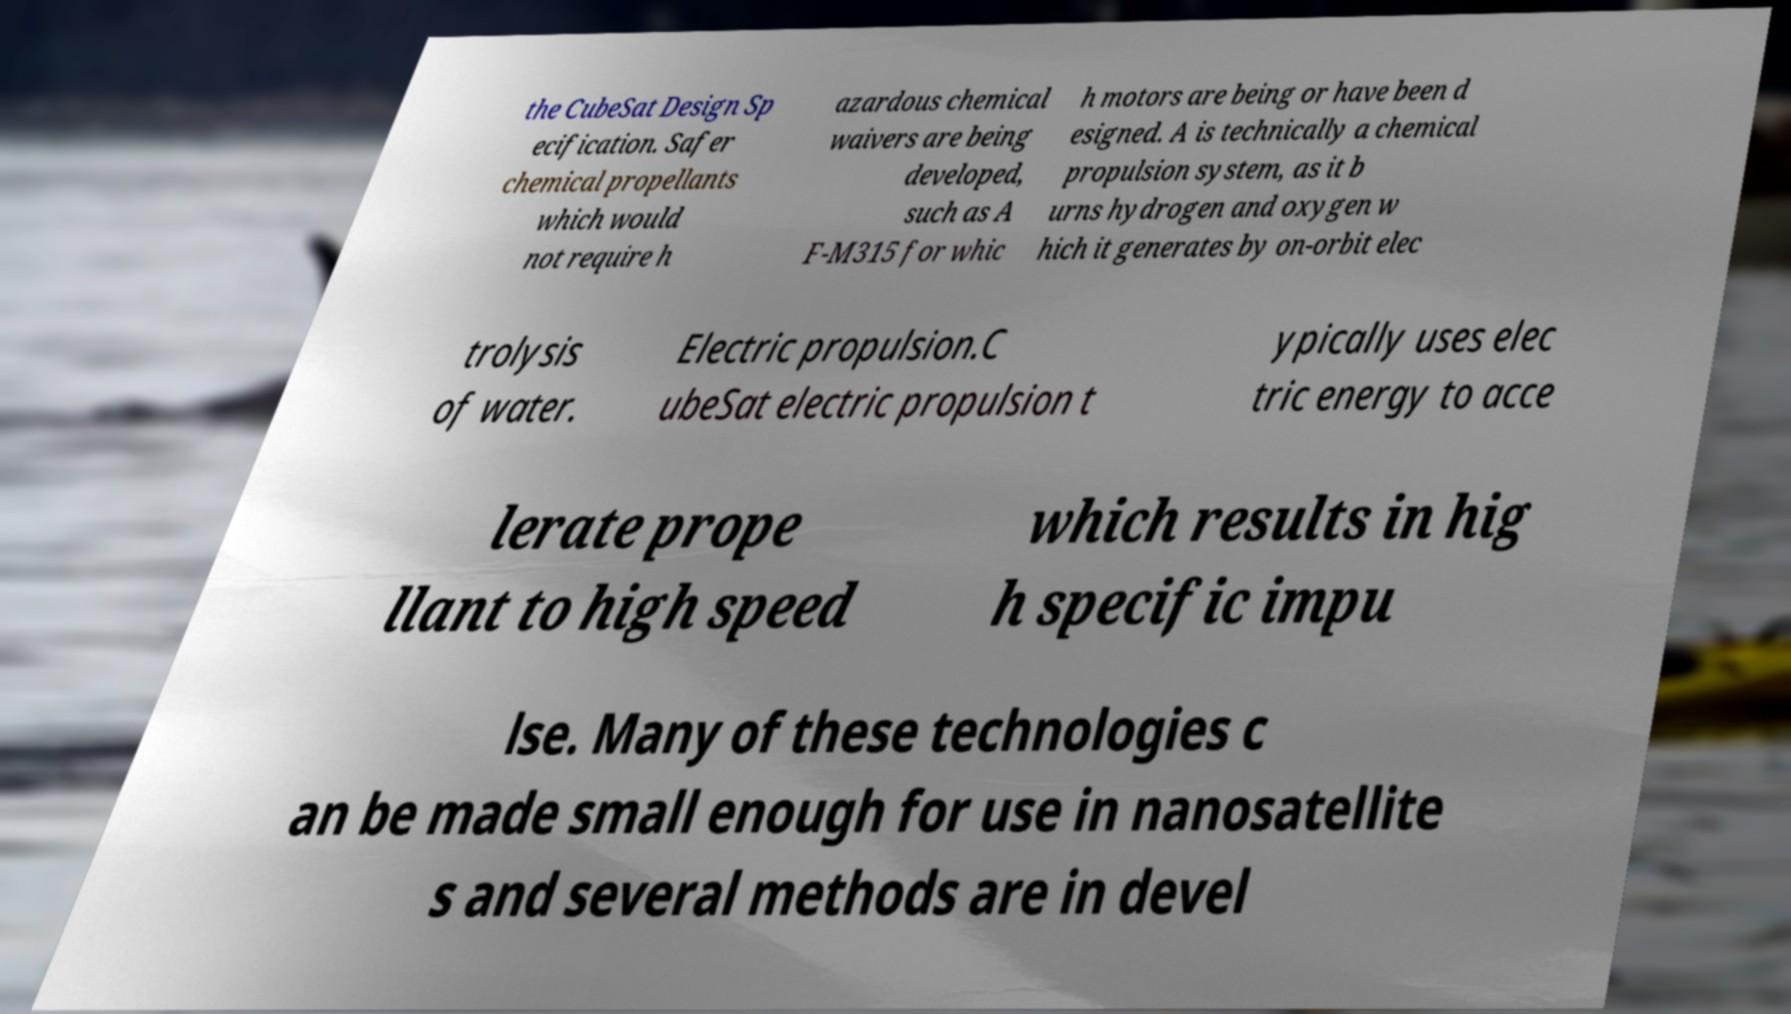Can you accurately transcribe the text from the provided image for me? the CubeSat Design Sp ecification. Safer chemical propellants which would not require h azardous chemical waivers are being developed, such as A F-M315 for whic h motors are being or have been d esigned. A is technically a chemical propulsion system, as it b urns hydrogen and oxygen w hich it generates by on-orbit elec trolysis of water. Electric propulsion.C ubeSat electric propulsion t ypically uses elec tric energy to acce lerate prope llant to high speed which results in hig h specific impu lse. Many of these technologies c an be made small enough for use in nanosatellite s and several methods are in devel 